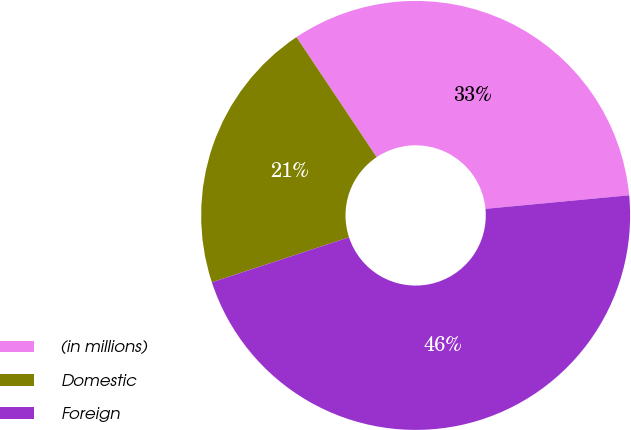<chart> <loc_0><loc_0><loc_500><loc_500><pie_chart><fcel>(in millions)<fcel>Domestic<fcel>Foreign<nl><fcel>32.88%<fcel>20.67%<fcel>46.45%<nl></chart> 